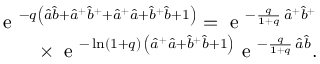<formula> <loc_0><loc_0><loc_500><loc_500>\begin{array} { r } { e ^ { - q { \left ( { \hat { a } } { \hat { b } } + { { \hat { a } } } ^ { + } { { \hat { b } } } ^ { + } + { { \hat { a } } } ^ { + } { \hat { a } } + { { \hat { b } } } ^ { + } { \hat { b } } + 1 \right ) } } = e ^ { - \frac { q } { 1 + q } \, { { \hat { a } } } ^ { + } { { \hat { b } } } ^ { + } } } \\ { \times \, e ^ { - \ln ( 1 + q ) \, \left ( { \hat { a } } ^ { + } { \hat { a } } + { \hat { b } } ^ { + } { \hat { b } } + 1 \right ) } e ^ { - \frac { q } { 1 + q } \, { \hat { a } } { \hat { b } } } . } \end{array}</formula> 